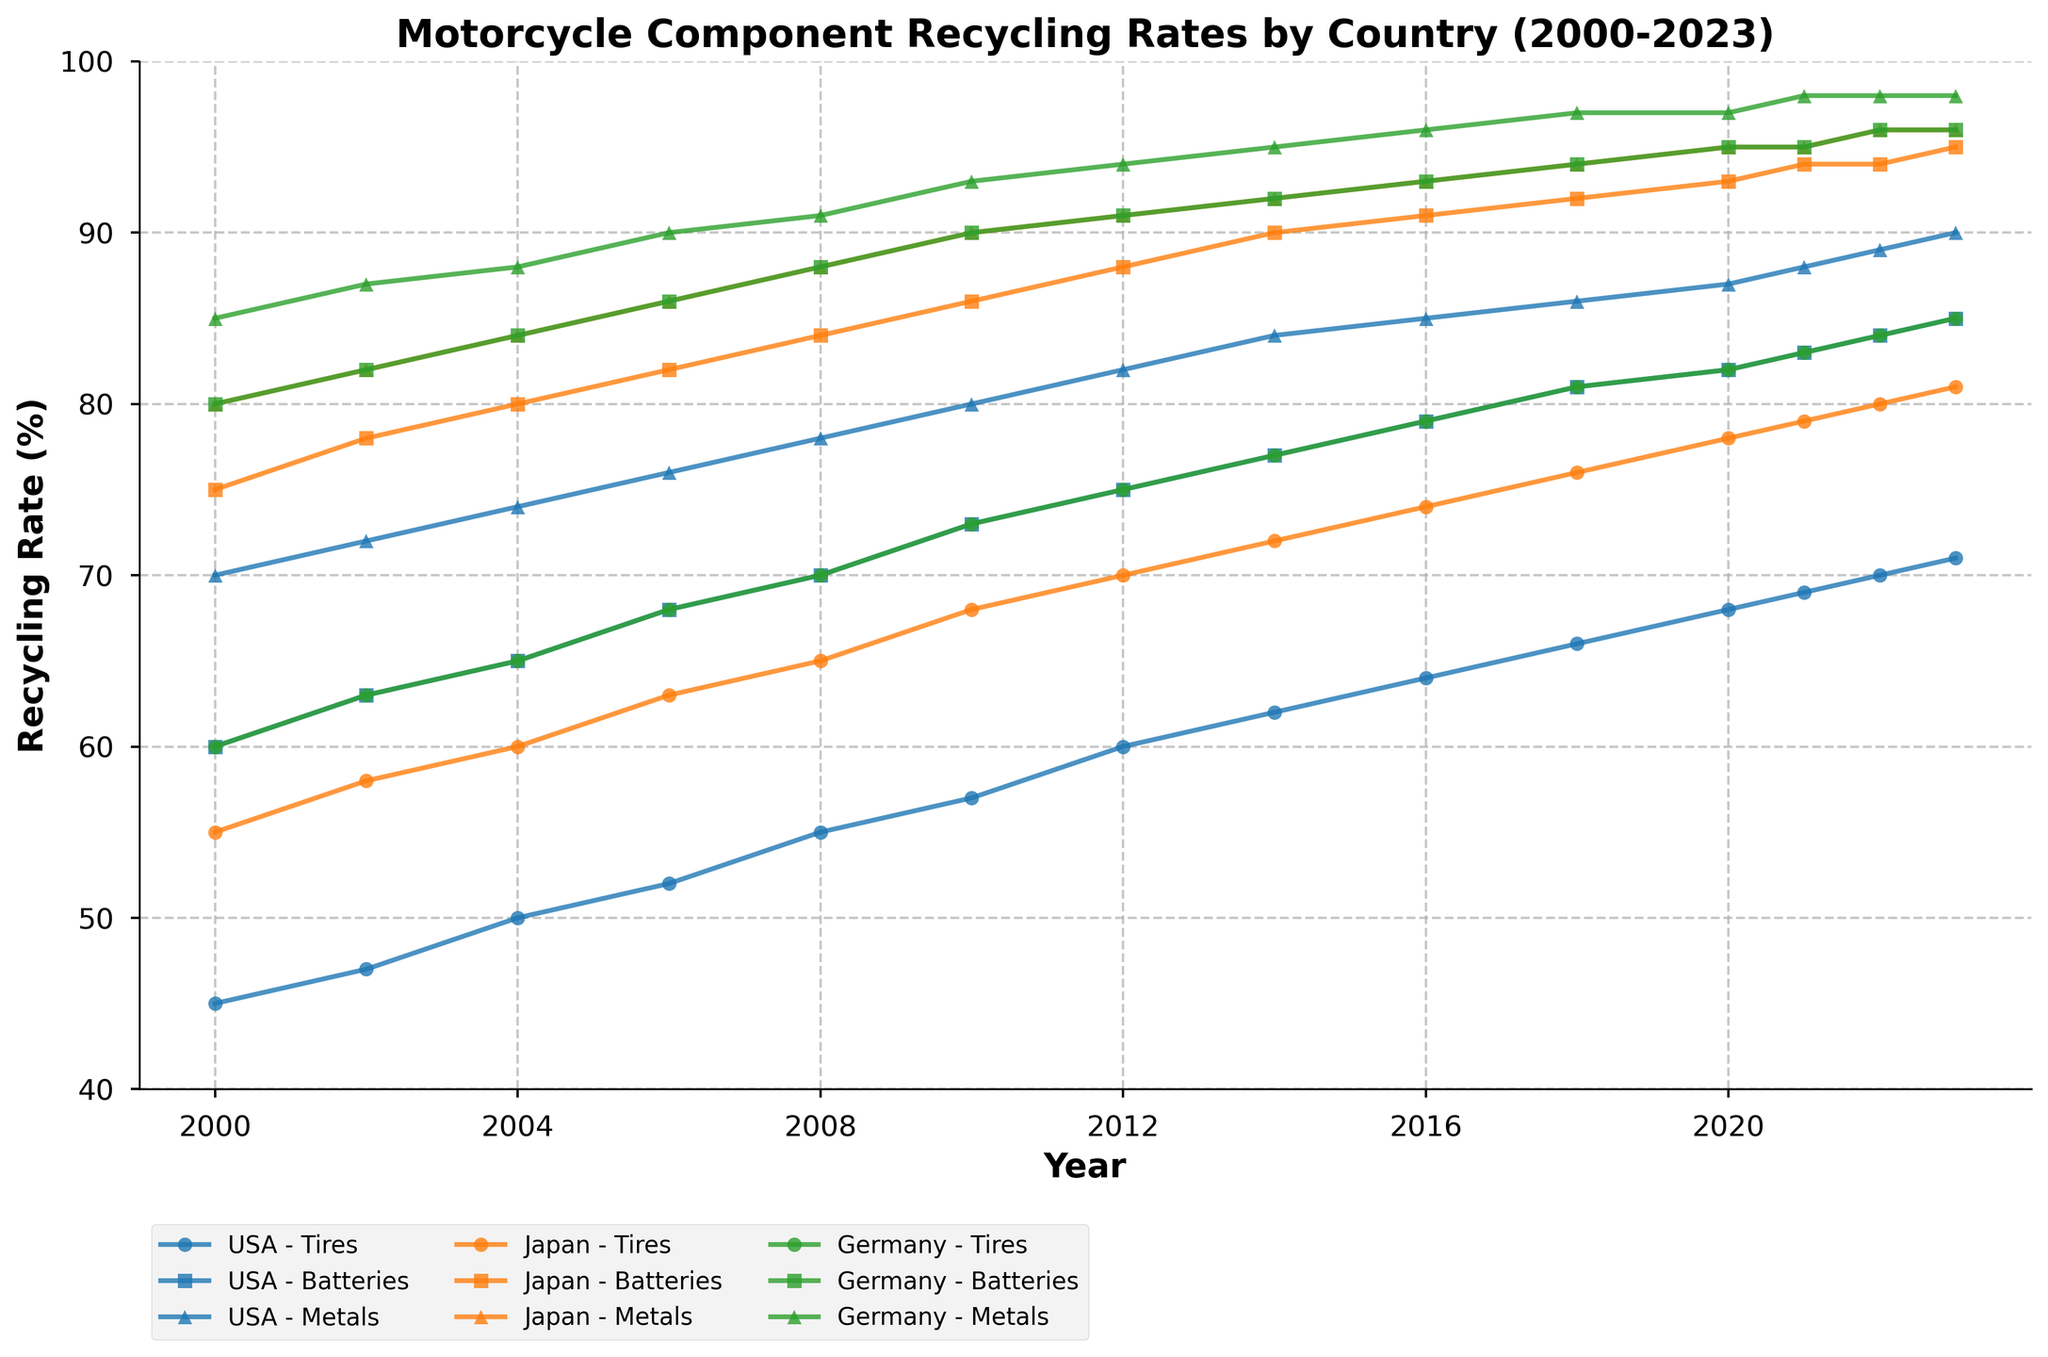what is the highest recycling rate achieved for motorcycle tires in Japan? The highest recycling rate for Japan's motorcycle tires is indicated by the peak of the line plot for Japan - Tires. The figure shows that the highest recycling rate achieved is at the end of the time range (2023).
Answer: 81% Which country achieved the highest recycling rate for motorcycle metals in 2023? By comparing the heights of the lines for 'Metals' across the three countries at the year 2023, Germany achieves the highest recycling rate.
Answer: Germany Over the years, which component showed the most improvement in recycling rate in the USA? To determine the component that showed the most improvement, calculate the difference between the recycling rates from 2000 to 2023 for tires, batteries, and metals. USA_Tires: \(71 - 45 = 26\), USA_Batteries: \(85 - 60 = 25\), USA_Metals: \(90 - 70 = 20\). The tires showed the most improvement.
Answer: Tires Comparing the recycling rates in 2010, which country had the highest rate for motorcycle batteries? In the year 2010, compare the recycling rates for batteries across the USA, Japan, and Germany. The figure shows that Japan had the highest rate.
Answer: Japan How did Germany's recycling rate for motorcycle metals in 2008 compare to USA's rate in the same year? Locate the data points for Germany - Metals and USA - Metals in 2008, and compare their heights. Germany's rate is 91%, USA's rate is 78%, showing that Germany's rate is higher.
Answer: Germany had a higher rate What is the average recycling rate for motorcycle batteries in the USA between 2000 and 2023? The average recycling rate for batteries is calculated by summing all the recycling rates for USA_Batteries and dividing by the number of years. Summing: \(60 + 63 + 65 + 68 + 70 + 73 + 75 + 77 + 79 + 81 + 82 + 83 + 84 + 85 = 1075\). Number of years = 14. Thus, average = \(1075 / 14\).
Answer: 76.8% Which country's recycling rates for motorcycle tires showed consistent improvement each year? Observe the trend of the line for tires for each country from 2000 to 2023. Germany's line for tires shows a consistent upward trend without any declines, indicating consistent improvement.
Answer: Germany For the year 2020, which motorcycle component had the lowest recycling rate in Japan? Look at the data points for Japan in 2020 and compare the recycling rates for tires, batteries, and metals. The recycling rate for tires (78%) is the lowest among all components for that year in Japan.
Answer: Tires 